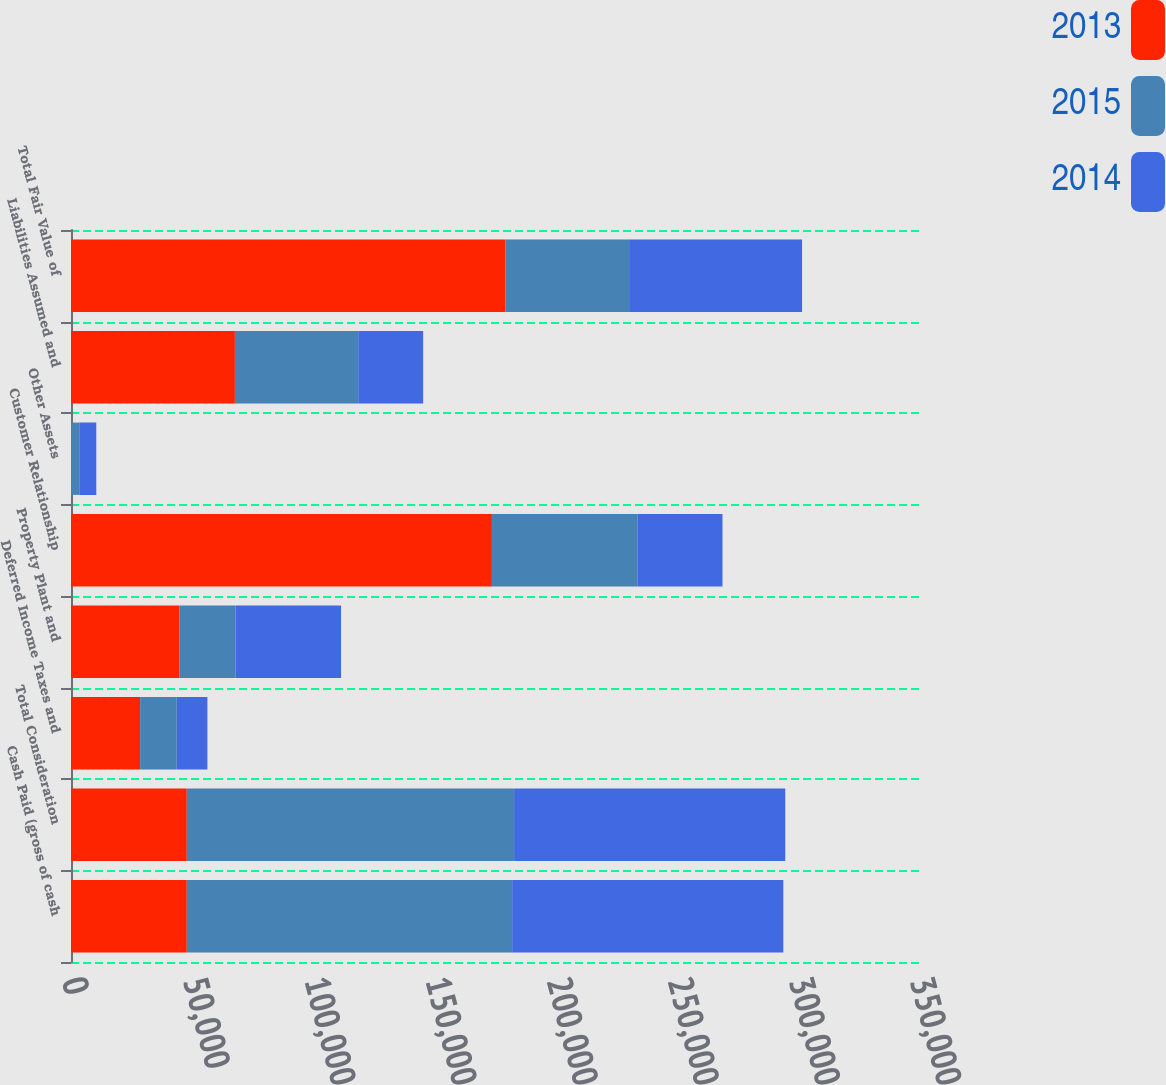Convert chart to OTSL. <chart><loc_0><loc_0><loc_500><loc_500><stacked_bar_chart><ecel><fcel>Cash Paid (gross of cash<fcel>Total Consideration<fcel>Deferred Income Taxes and<fcel>Property Plant and<fcel>Customer Relationship<fcel>Other Assets<fcel>Liabilities Assumed and<fcel>Total Fair Value of<nl><fcel>2013<fcel>47792<fcel>47792<fcel>28532<fcel>44681<fcel>173733<fcel>68<fcel>67645<fcel>179369<nl><fcel>2015<fcel>134301<fcel>135095<fcel>15098<fcel>23269<fcel>60172<fcel>3342<fcel>50903<fcel>50978<nl><fcel>2014<fcel>111907<fcel>111907<fcel>12670<fcel>43505<fcel>34988<fcel>7032<fcel>26807<fcel>71388<nl></chart> 